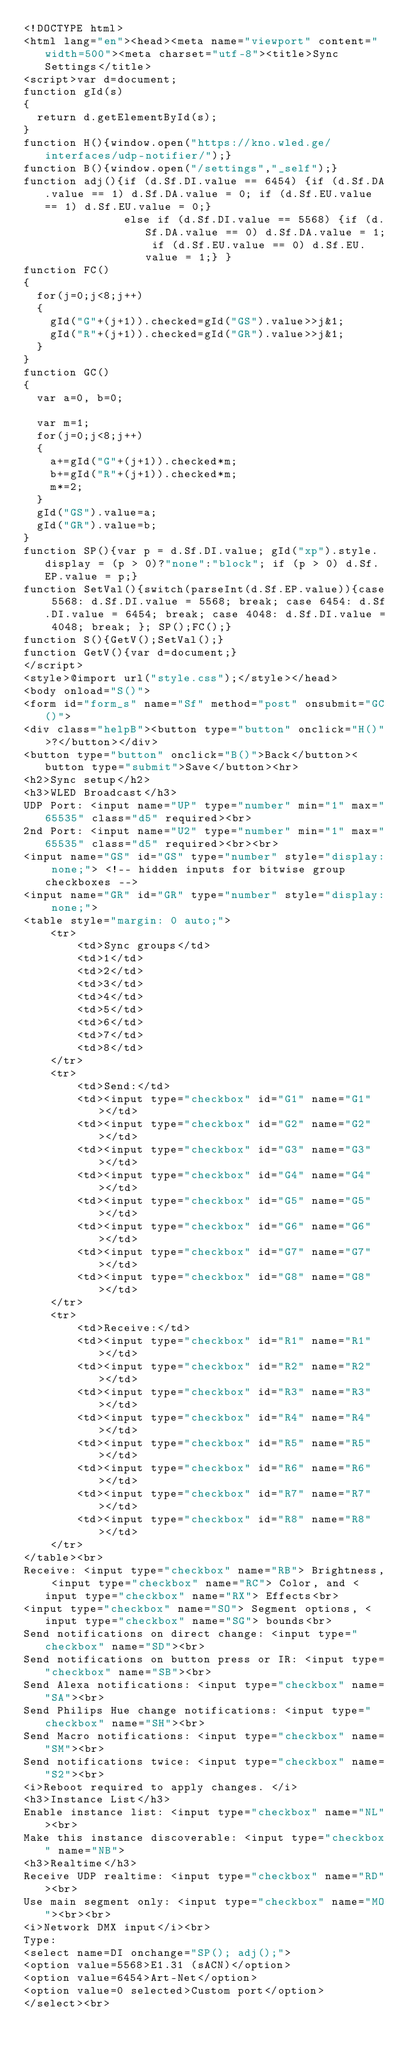Convert code to text. <code><loc_0><loc_0><loc_500><loc_500><_HTML_><!DOCTYPE html>
<html lang="en"><head><meta name="viewport" content="width=500"><meta charset="utf-8"><title>Sync Settings</title>
<script>var d=document;
function gId(s)
{
  return d.getElementById(s);
}
function H(){window.open("https://kno.wled.ge/interfaces/udp-notifier/");}
function B(){window.open("/settings","_self");}
function adj(){if (d.Sf.DI.value == 6454) {if (d.Sf.DA.value == 1) d.Sf.DA.value = 0; if (d.Sf.EU.value == 1) d.Sf.EU.value = 0;}
               else if (d.Sf.DI.value == 5568) {if (d.Sf.DA.value == 0) d.Sf.DA.value = 1; if (d.Sf.EU.value == 0) d.Sf.EU.value = 1;} }
function FC()
{
  for(j=0;j<8;j++)
  {
    gId("G"+(j+1)).checked=gId("GS").value>>j&1;
    gId("R"+(j+1)).checked=gId("GR").value>>j&1;
  }
}
function GC()
{
  var a=0, b=0;

  var m=1;
  for(j=0;j<8;j++)
  {
    a+=gId("G"+(j+1)).checked*m;
    b+=gId("R"+(j+1)).checked*m;
    m*=2;
  }
  gId("GS").value=a;
  gId("GR").value=b;
}
function SP(){var p = d.Sf.DI.value; gId("xp").style.display = (p > 0)?"none":"block"; if (p > 0) d.Sf.EP.value = p;}
function SetVal(){switch(parseInt(d.Sf.EP.value)){case 5568: d.Sf.DI.value = 5568; break; case 6454: d.Sf.DI.value = 6454; break; case 4048: d.Sf.DI.value = 4048; break; }; SP();FC();}
function S(){GetV();SetVal();}
function GetV(){var d=document;}
</script>
<style>@import url("style.css");</style></head>
<body onload="S()">
<form id="form_s" name="Sf" method="post" onsubmit="GC()">
<div class="helpB"><button type="button" onclick="H()">?</button></div>
<button type="button" onclick="B()">Back</button><button type="submit">Save</button><hr>
<h2>Sync setup</h2>
<h3>WLED Broadcast</h3>
UDP Port: <input name="UP" type="number" min="1" max="65535" class="d5" required><br>
2nd Port: <input name="U2" type="number" min="1" max="65535" class="d5" required><br><br>
<input name="GS" id="GS" type="number" style="display: none;"> <!-- hidden inputs for bitwise group checkboxes -->
<input name="GR" id="GR" type="number" style="display: none;">
<table style="margin: 0 auto;">
    <tr>
        <td>Sync groups</td>
        <td>1</td>
        <td>2</td>
        <td>3</td>
        <td>4</td>
        <td>5</td>
        <td>6</td>
        <td>7</td>
        <td>8</td>
    </tr>
    <tr>
        <td>Send:</td>
        <td><input type="checkbox" id="G1" name="G1"></td>
        <td><input type="checkbox" id="G2" name="G2"></td>
        <td><input type="checkbox" id="G3" name="G3"></td>
        <td><input type="checkbox" id="G4" name="G4"></td>
        <td><input type="checkbox" id="G5" name="G5"></td>
        <td><input type="checkbox" id="G6" name="G6"></td>
        <td><input type="checkbox" id="G7" name="G7"></td>
        <td><input type="checkbox" id="G8" name="G8"></td>
    </tr>
    <tr>
        <td>Receive:</td>
        <td><input type="checkbox" id="R1" name="R1"></td>
        <td><input type="checkbox" id="R2" name="R2"></td>
        <td><input type="checkbox" id="R3" name="R3"></td>
        <td><input type="checkbox" id="R4" name="R4"></td>
        <td><input type="checkbox" id="R5" name="R5"></td>
        <td><input type="checkbox" id="R6" name="R6"></td>
        <td><input type="checkbox" id="R7" name="R7"></td>
        <td><input type="checkbox" id="R8" name="R8"></td>
    </tr>
</table><br>
Receive: <input type="checkbox" name="RB"> Brightness, <input type="checkbox" name="RC"> Color, and <input type="checkbox" name="RX"> Effects<br>
<input type="checkbox" name="SO"> Segment options, <input type="checkbox" name="SG"> bounds<br>
Send notifications on direct change: <input type="checkbox" name="SD"><br>
Send notifications on button press or IR: <input type="checkbox" name="SB"><br>
Send Alexa notifications: <input type="checkbox" name="SA"><br>
Send Philips Hue change notifications: <input type="checkbox" name="SH"><br>
Send Macro notifications: <input type="checkbox" name="SM"><br>
Send notifications twice: <input type="checkbox" name="S2"><br>
<i>Reboot required to apply changes. </i>
<h3>Instance List</h3>
Enable instance list: <input type="checkbox" name="NL"><br>
Make this instance discoverable: <input type="checkbox" name="NB">
<h3>Realtime</h3>
Receive UDP realtime: <input type="checkbox" name="RD"><br>
Use main segment only: <input type="checkbox" name="MO"><br><br>
<i>Network DMX input</i><br>
Type:
<select name=DI onchange="SP(); adj();">
<option value=5568>E1.31 (sACN)</option>
<option value=6454>Art-Net</option>
<option value=0 selected>Custom port</option>
</select><br></code> 